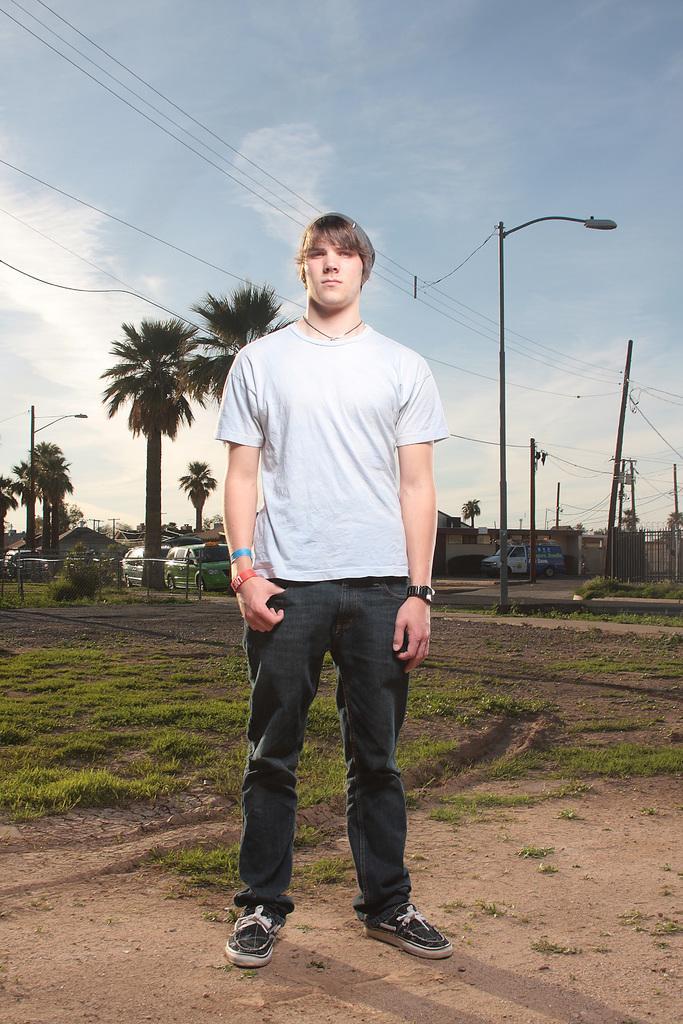In one or two sentences, can you explain what this image depicts? In the foreground of this image, there is a man standing on the ground. In the background, there is grass, trees, poles, few vehicles, houses, cables, sky and the cloud. 